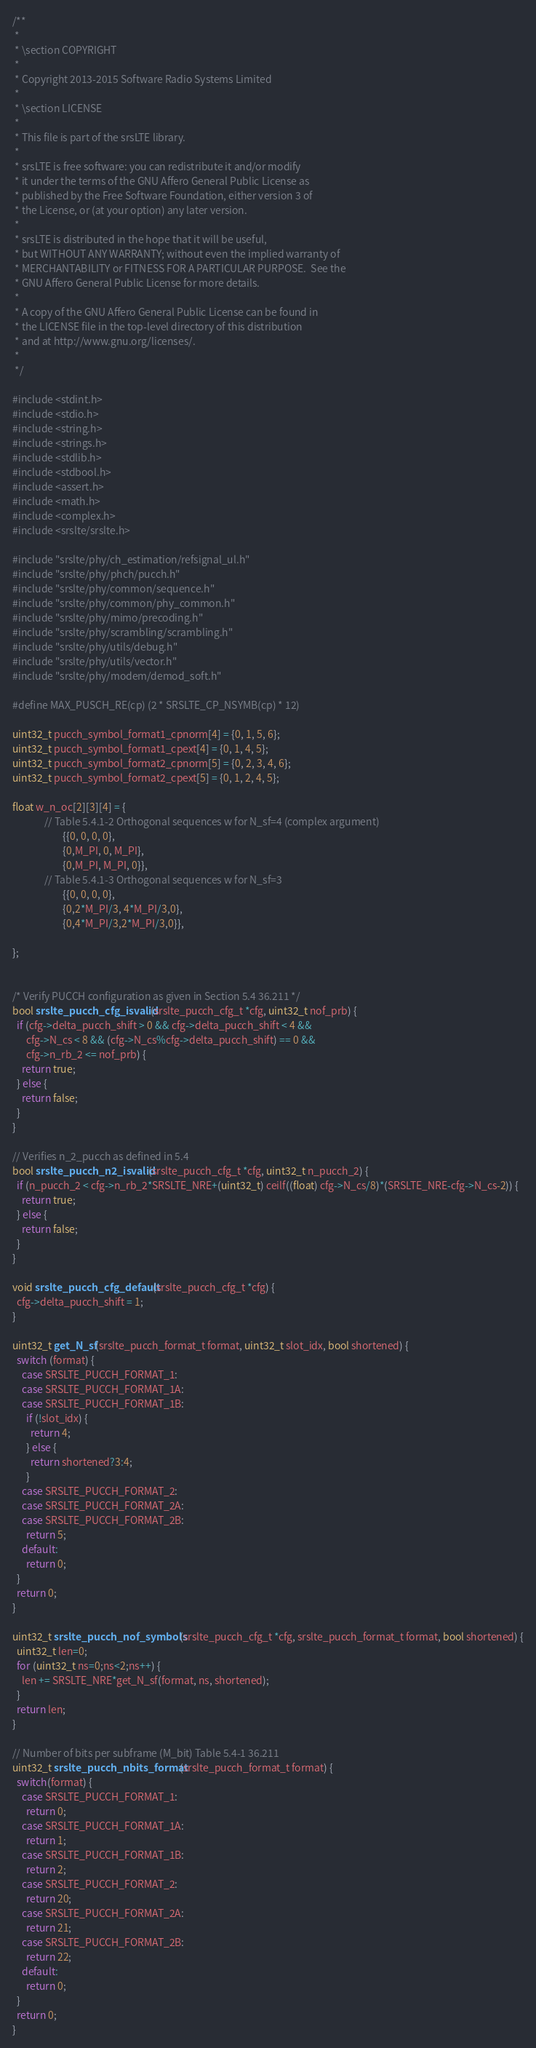Convert code to text. <code><loc_0><loc_0><loc_500><loc_500><_C_>/**
 *
 * \section COPYRIGHT
 *
 * Copyright 2013-2015 Software Radio Systems Limited
 *
 * \section LICENSE
 *
 * This file is part of the srsLTE library.
 *
 * srsLTE is free software: you can redistribute it and/or modify
 * it under the terms of the GNU Affero General Public License as
 * published by the Free Software Foundation, either version 3 of
 * the License, or (at your option) any later version.
 *
 * srsLTE is distributed in the hope that it will be useful,
 * but WITHOUT ANY WARRANTY; without even the implied warranty of
 * MERCHANTABILITY or FITNESS FOR A PARTICULAR PURPOSE.  See the
 * GNU Affero General Public License for more details.
 *
 * A copy of the GNU Affero General Public License can be found in
 * the LICENSE file in the top-level directory of this distribution
 * and at http://www.gnu.org/licenses/.
 *
 */

#include <stdint.h>
#include <stdio.h>
#include <string.h>
#include <strings.h>
#include <stdlib.h>
#include <stdbool.h>
#include <assert.h>
#include <math.h>
#include <complex.h>
#include <srslte/srslte.h>

#include "srslte/phy/ch_estimation/refsignal_ul.h"
#include "srslte/phy/phch/pucch.h"
#include "srslte/phy/common/sequence.h"
#include "srslte/phy/common/phy_common.h"
#include "srslte/phy/mimo/precoding.h"
#include "srslte/phy/scrambling/scrambling.h"
#include "srslte/phy/utils/debug.h"
#include "srslte/phy/utils/vector.h"
#include "srslte/phy/modem/demod_soft.h"

#define MAX_PUSCH_RE(cp) (2 * SRSLTE_CP_NSYMB(cp) * 12)

uint32_t pucch_symbol_format1_cpnorm[4] = {0, 1, 5, 6};
uint32_t pucch_symbol_format1_cpext[4] = {0, 1, 4, 5};
uint32_t pucch_symbol_format2_cpnorm[5] = {0, 2, 3, 4, 6};
uint32_t pucch_symbol_format2_cpext[5] = {0, 1, 2, 4, 5};

float w_n_oc[2][3][4] = {
              // Table 5.4.1-2 Orthogonal sequences w for N_sf=4 (complex argument)
                      {{0, 0, 0, 0},
                      {0,M_PI, 0, M_PI},
                      {0,M_PI, M_PI, 0}}, 
              // Table 5.4.1-3 Orthogonal sequences w for N_sf=3
                      {{0, 0, 0, 0},
                      {0,2*M_PI/3, 4*M_PI/3,0},
                      {0,4*M_PI/3,2*M_PI/3,0}}, 
  
};


/* Verify PUCCH configuration as given in Section 5.4 36.211 */
bool srslte_pucch_cfg_isvalid(srslte_pucch_cfg_t *cfg, uint32_t nof_prb) {
  if (cfg->delta_pucch_shift > 0 && cfg->delta_pucch_shift < 4 &&
      cfg->N_cs < 8 && (cfg->N_cs%cfg->delta_pucch_shift) == 0 && 
      cfg->n_rb_2 <= nof_prb) {
    return true; 
  } else {
    return false;    
  }
}

// Verifies n_2_pucch as defined in 5.4
bool srslte_pucch_n2_isvalid(srslte_pucch_cfg_t *cfg, uint32_t n_pucch_2) {
  if (n_pucch_2 < cfg->n_rb_2*SRSLTE_NRE+(uint32_t) ceilf((float) cfg->N_cs/8)*(SRSLTE_NRE-cfg->N_cs-2)) {
    return true; 
  } else {
    return false; 
  }
}

void srslte_pucch_cfg_default(srslte_pucch_cfg_t *cfg) {
  cfg->delta_pucch_shift = 1; 
}

uint32_t get_N_sf(srslte_pucch_format_t format, uint32_t slot_idx, bool shortened) {
  switch (format) {
    case SRSLTE_PUCCH_FORMAT_1:
    case SRSLTE_PUCCH_FORMAT_1A:
    case SRSLTE_PUCCH_FORMAT_1B:
      if (!slot_idx) {
        return 4; 
      } else {
        return shortened?3:4; 
      }
    case SRSLTE_PUCCH_FORMAT_2:
    case SRSLTE_PUCCH_FORMAT_2A:
    case SRSLTE_PUCCH_FORMAT_2B:    
      return 5; 
    default: 
      return 0; 
  }
  return 0; 
}

uint32_t srslte_pucch_nof_symbols(srslte_pucch_cfg_t *cfg, srslte_pucch_format_t format, bool shortened) {
  uint32_t len=0;
  for (uint32_t ns=0;ns<2;ns++) {
    len += SRSLTE_NRE*get_N_sf(format, ns, shortened);
  }
  return len; 
}

// Number of bits per subframe (M_bit) Table 5.4-1 36.211 
uint32_t srslte_pucch_nbits_format(srslte_pucch_format_t format) {
  switch(format) {
    case SRSLTE_PUCCH_FORMAT_1:
      return 0; 
    case SRSLTE_PUCCH_FORMAT_1A:
      return 1; 
    case SRSLTE_PUCCH_FORMAT_1B:
      return 2; 
    case SRSLTE_PUCCH_FORMAT_2:
      return 20; 
    case SRSLTE_PUCCH_FORMAT_2A:
      return 21; 
    case SRSLTE_PUCCH_FORMAT_2B:
      return 22; 
    default:
      return 0; 
  }
  return 0; 
}
</code> 